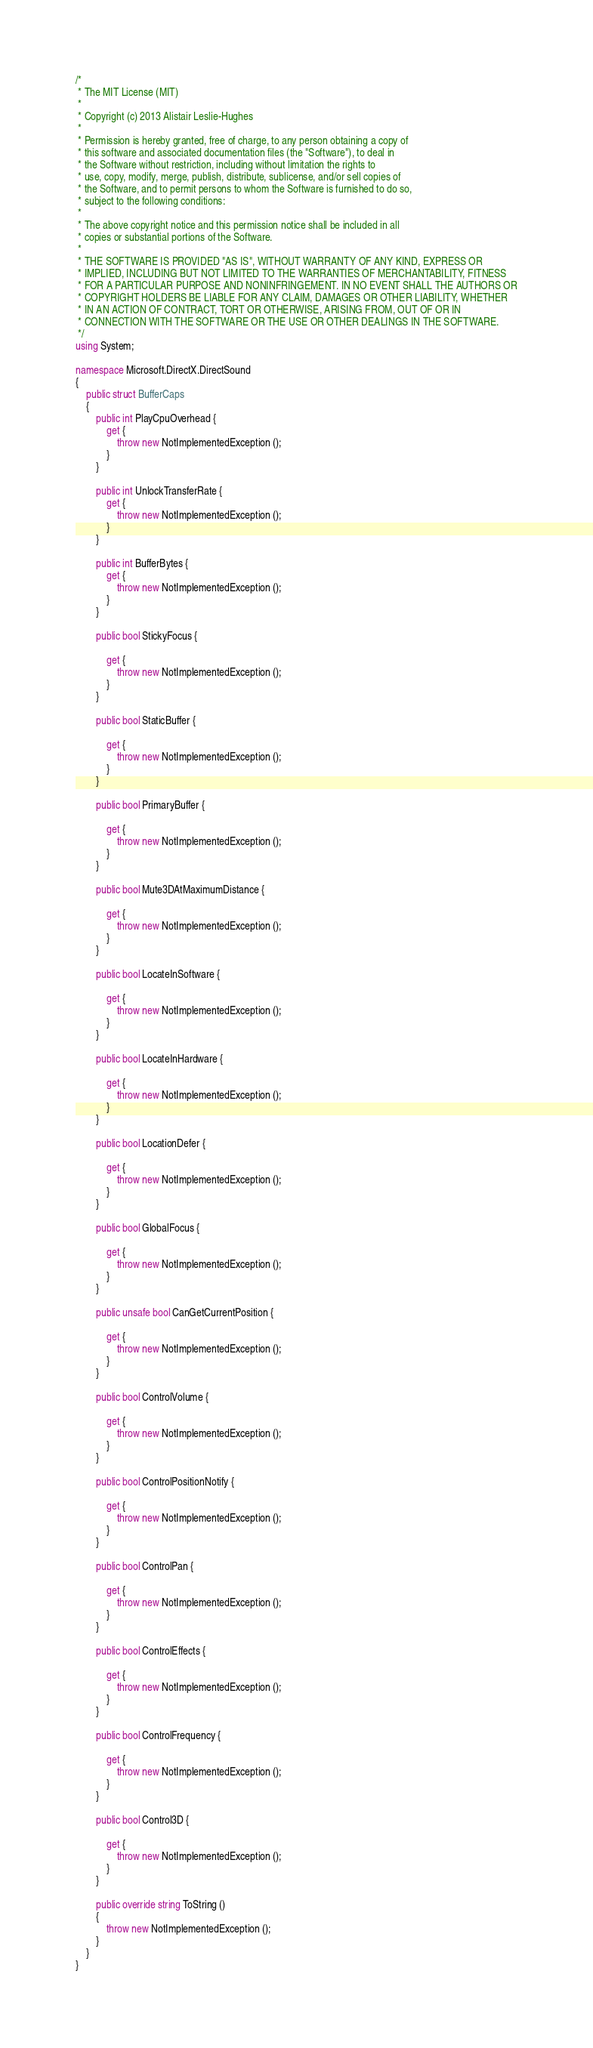<code> <loc_0><loc_0><loc_500><loc_500><_C#_>/*
 * The MIT License (MIT)
 *
 * Copyright (c) 2013 Alistair Leslie-Hughes
 *
 * Permission is hereby granted, free of charge, to any person obtaining a copy of
 * this software and associated documentation files (the "Software"), to deal in
 * the Software without restriction, including without limitation the rights to
 * use, copy, modify, merge, publish, distribute, sublicense, and/or sell copies of
 * the Software, and to permit persons to whom the Software is furnished to do so,
 * subject to the following conditions:
 *
 * The above copyright notice and this permission notice shall be included in all
 * copies or substantial portions of the Software.
 *
 * THE SOFTWARE IS PROVIDED "AS IS", WITHOUT WARRANTY OF ANY KIND, EXPRESS OR
 * IMPLIED, INCLUDING BUT NOT LIMITED TO THE WARRANTIES OF MERCHANTABILITY, FITNESS
 * FOR A PARTICULAR PURPOSE AND NONINFRINGEMENT. IN NO EVENT SHALL THE AUTHORS OR
 * COPYRIGHT HOLDERS BE LIABLE FOR ANY CLAIM, DAMAGES OR OTHER LIABILITY, WHETHER
 * IN AN ACTION OF CONTRACT, TORT OR OTHERWISE, ARISING FROM, OUT OF OR IN
 * CONNECTION WITH THE SOFTWARE OR THE USE OR OTHER DEALINGS IN THE SOFTWARE.
 */
using System;

namespace Microsoft.DirectX.DirectSound
{
	public struct BufferCaps
	{
		public int PlayCpuOverhead {
			get {
				throw new NotImplementedException ();
			}
		}

		public int UnlockTransferRate {
			get {
				throw new NotImplementedException ();
			}
		}

		public int BufferBytes {
			get {
				throw new NotImplementedException ();
			}
		}

		public bool StickyFocus {
			
			get {
				throw new NotImplementedException ();
			}
		}

		public bool StaticBuffer {
			
			get {
				throw new NotImplementedException ();
			}
		}

		public bool PrimaryBuffer {
			
			get {
				throw new NotImplementedException ();
			}
		}

		public bool Mute3DAtMaximumDistance {
			
			get {
				throw new NotImplementedException ();
			}
		}

		public bool LocateInSoftware {
			
			get {
				throw new NotImplementedException ();
			}
		}

		public bool LocateInHardware {
			
			get {
				throw new NotImplementedException ();
			}
		}

		public bool LocationDefer {
			
			get {
				throw new NotImplementedException ();
			}
		}

		public bool GlobalFocus {
			
			get {
				throw new NotImplementedException ();
			}
		}

		public unsafe bool CanGetCurrentPosition {
			
			get {
				throw new NotImplementedException ();
			}
		}

		public bool ControlVolume {
			
			get {
				throw new NotImplementedException ();
			}
		}

		public bool ControlPositionNotify {
			
			get {
				throw new NotImplementedException ();
			}
		}

		public bool ControlPan {
			
			get {
				throw new NotImplementedException ();
			}
		}

		public bool ControlEffects {
			
			get {
				throw new NotImplementedException ();
			}
		}

		public bool ControlFrequency {
			
			get {
				throw new NotImplementedException ();
			}
		}

		public bool Control3D {
			
			get {
				throw new NotImplementedException ();
			}
		}

		public override string ToString ()
		{
			throw new NotImplementedException ();
		}
	}
}


</code> 